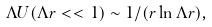Convert formula to latex. <formula><loc_0><loc_0><loc_500><loc_500>\Lambda U ( \Lambda r < < 1 ) \sim 1 / ( r \ln \Lambda r ) ,</formula> 